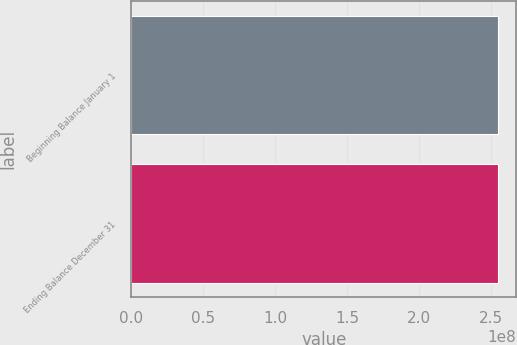Convert chart to OTSL. <chart><loc_0><loc_0><loc_500><loc_500><bar_chart><fcel>Beginning Balance January 1<fcel>Ending Balance December 31<nl><fcel>2.54753e+08<fcel>2.54753e+08<nl></chart> 